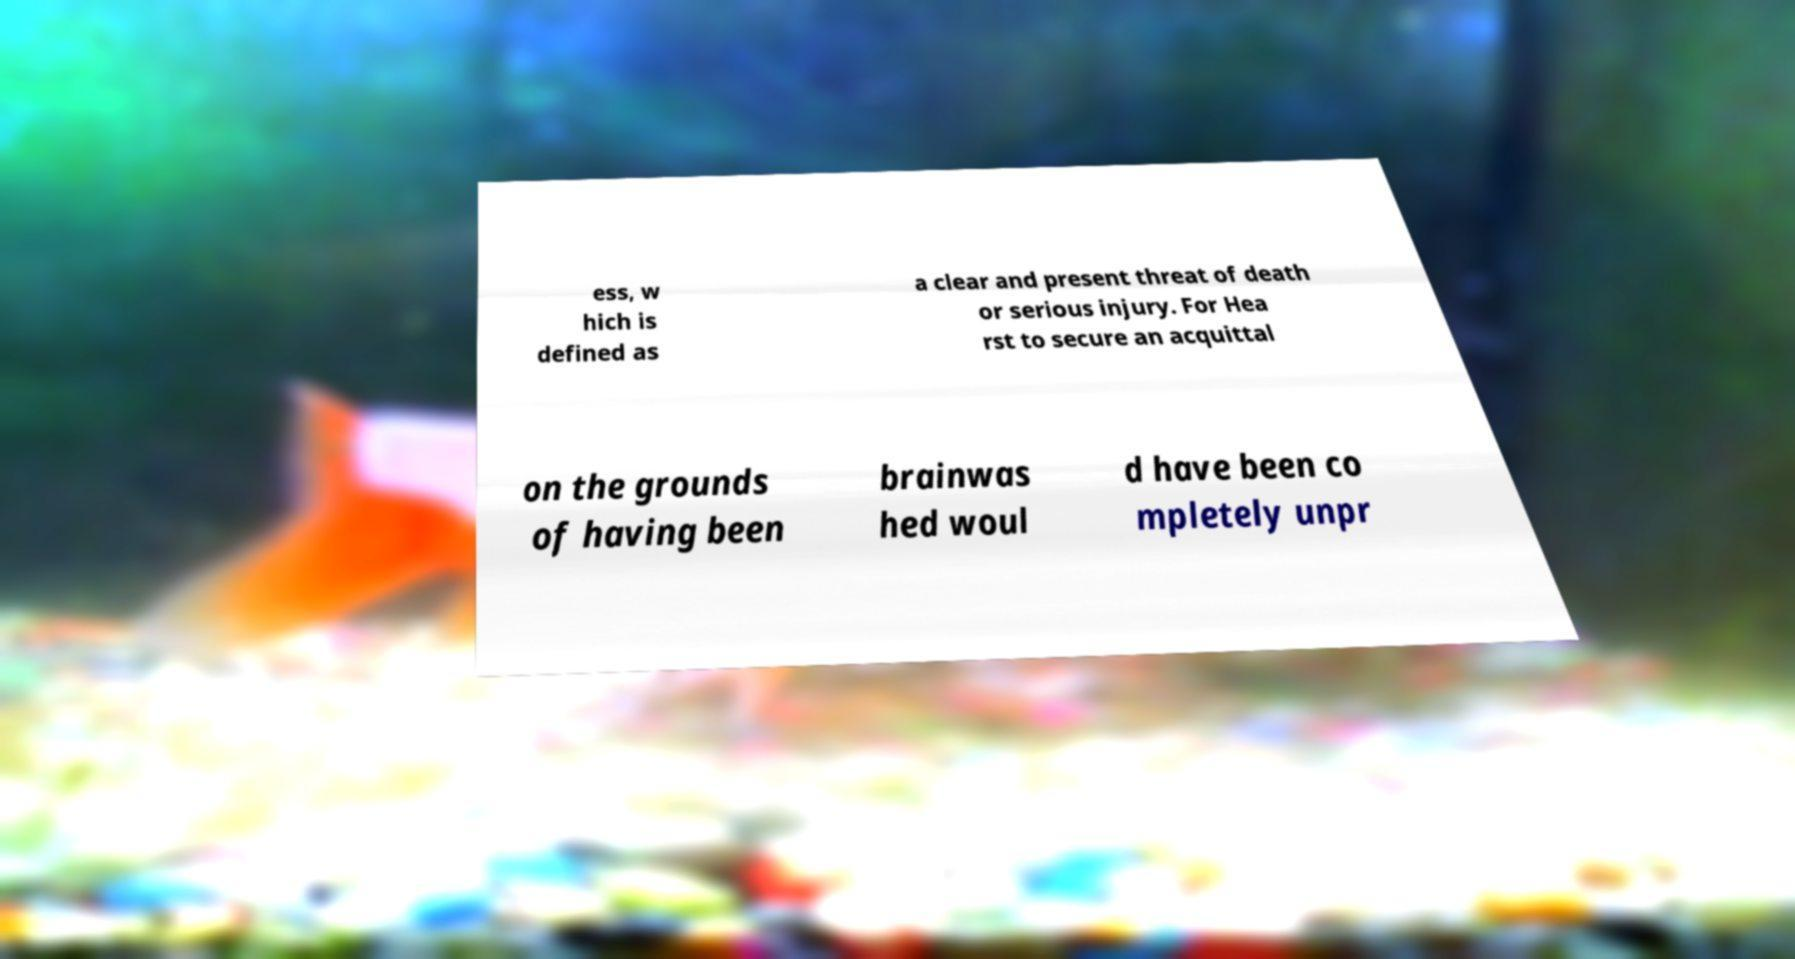Could you extract and type out the text from this image? ess, w hich is defined as a clear and present threat of death or serious injury. For Hea rst to secure an acquittal on the grounds of having been brainwas hed woul d have been co mpletely unpr 